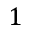Convert formula to latex. <formula><loc_0><loc_0><loc_500><loc_500>1</formula> 